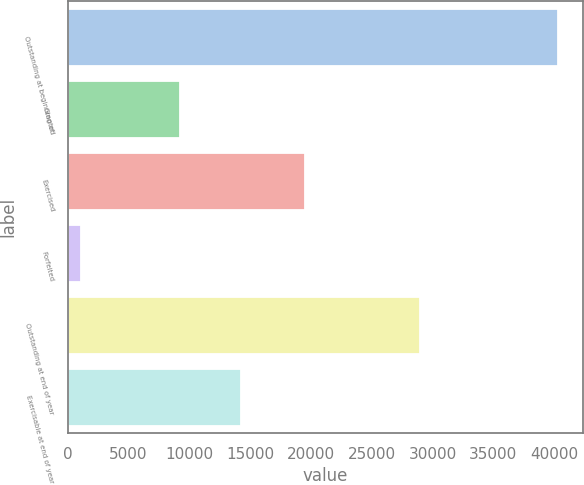Convert chart. <chart><loc_0><loc_0><loc_500><loc_500><bar_chart><fcel>Outstanding at beginning of<fcel>Granted<fcel>Exercised<fcel>Forfeited<fcel>Outstanding at end of year<fcel>Exercisable at end of year<nl><fcel>40311<fcel>9246<fcel>19533<fcel>1081<fcel>28943<fcel>14252<nl></chart> 